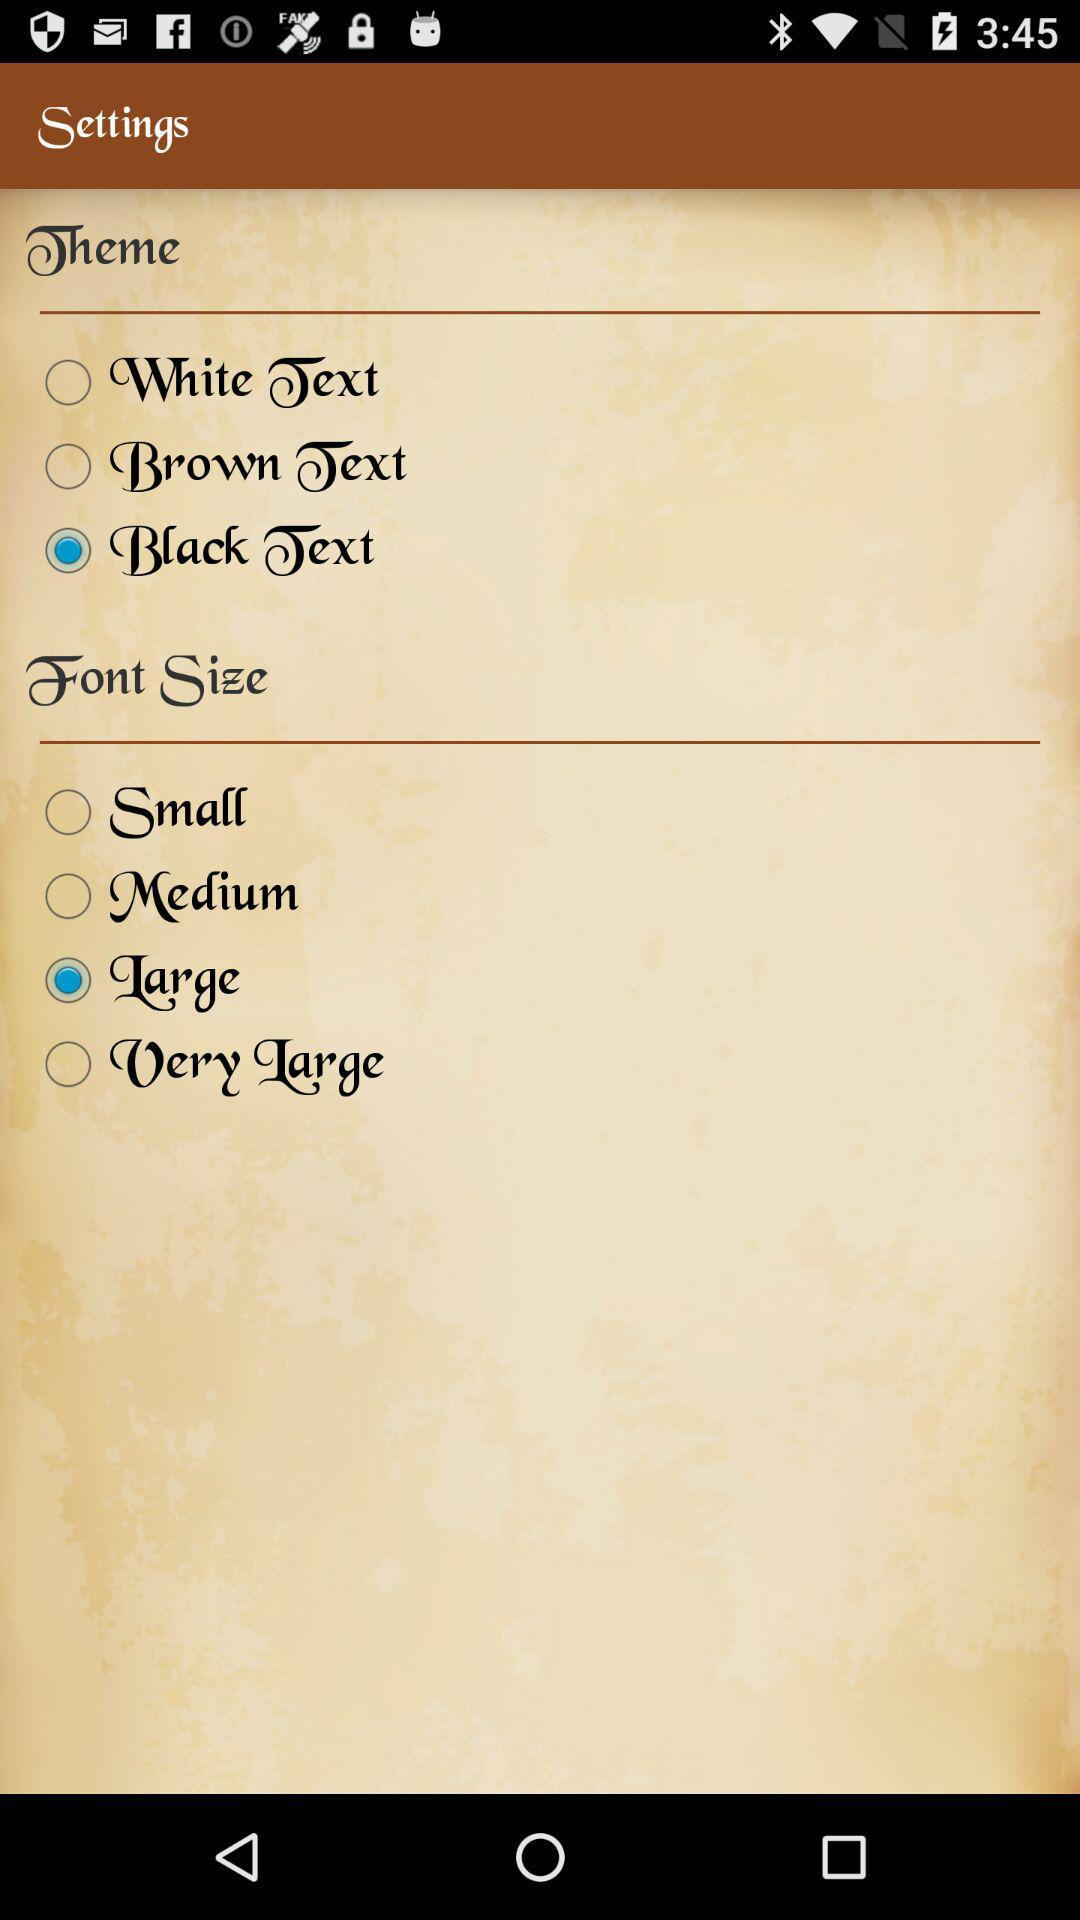What is the selected theme? The selected theme is "Black Text". 